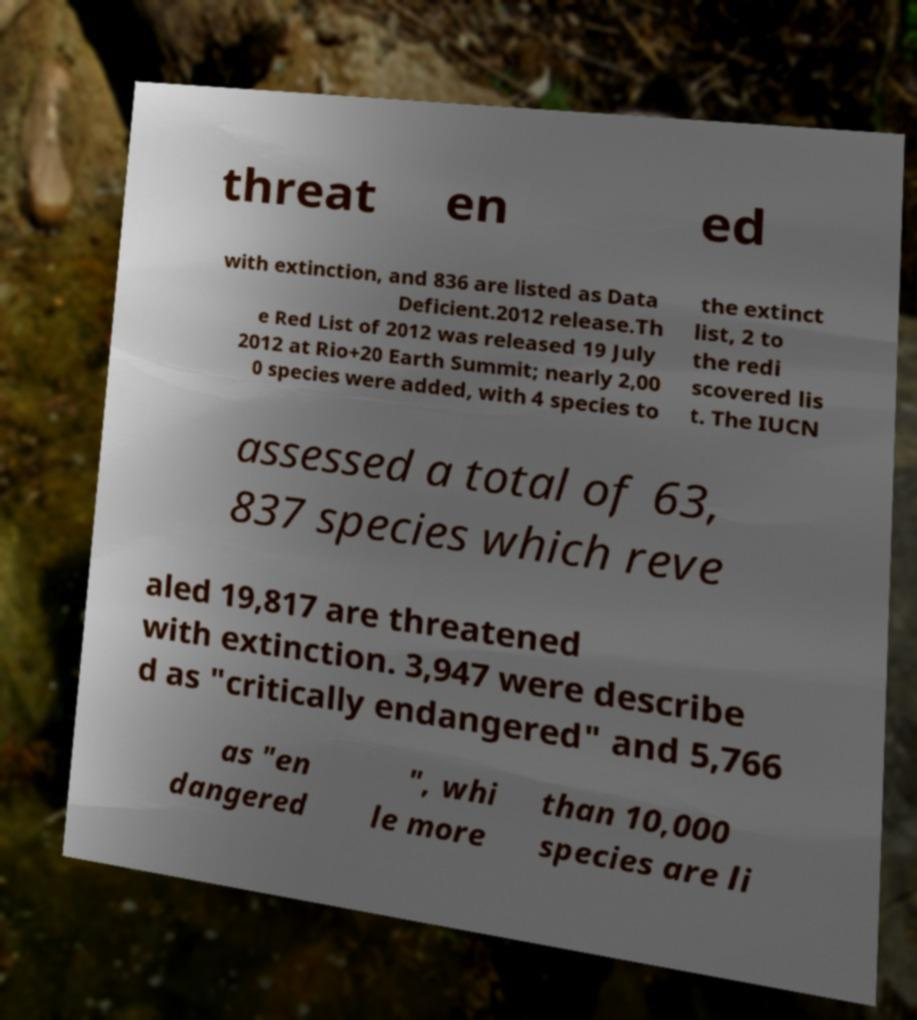What messages or text are displayed in this image? I need them in a readable, typed format. threat en ed with extinction, and 836 are listed as Data Deficient.2012 release.Th e Red List of 2012 was released 19 July 2012 at Rio+20 Earth Summit; nearly 2,00 0 species were added, with 4 species to the extinct list, 2 to the redi scovered lis t. The IUCN assessed a total of 63, 837 species which reve aled 19,817 are threatened with extinction. 3,947 were describe d as "critically endangered" and 5,766 as "en dangered ", whi le more than 10,000 species are li 